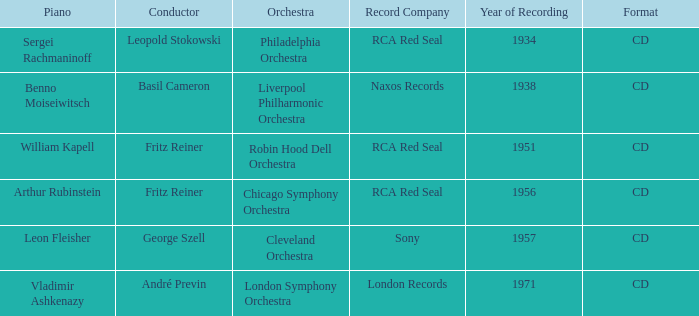Which orchestra has a recording year of 1951? Robin Hood Dell Orchestra. 